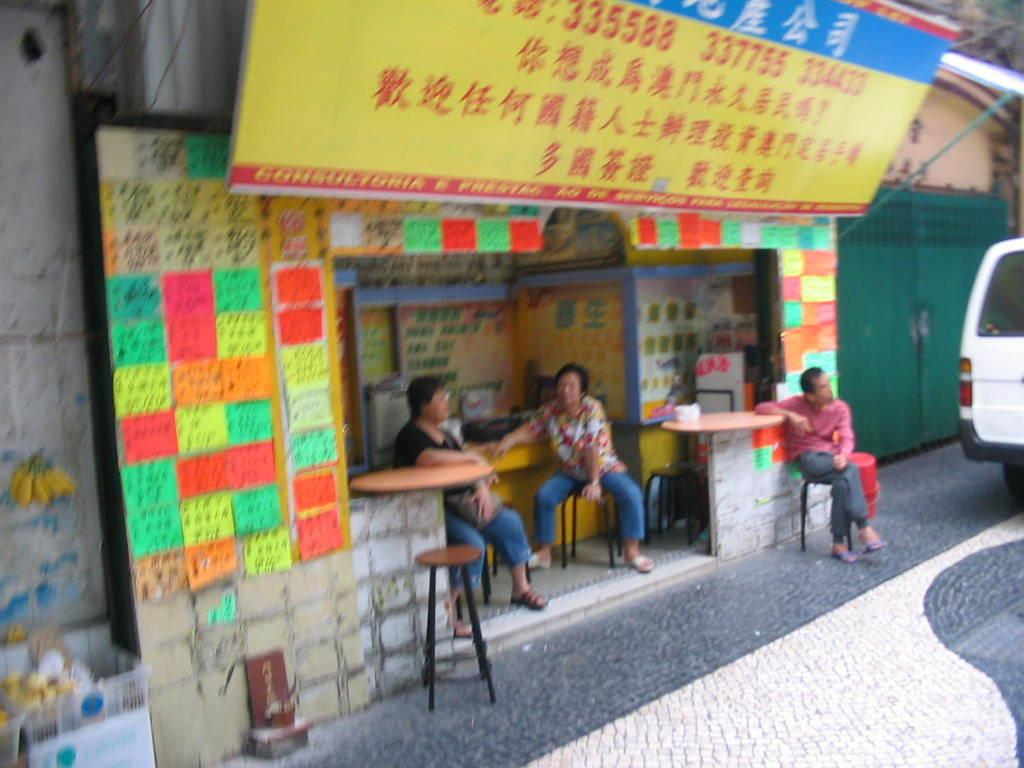How many people are in the image? There are three people in the image. What are the people doing in the image? The people are sitting on stools. What can be seen on the walls in the image? There are posters in the image. What is the location of the gates in the image? The gates are in the image. What is on the road in the image? There is a vehicle on the road in the image. What is used for carrying items in the image? There is a basket in the image for carrying items. Can you describe the unspecified objects in the image? Unfortunately, the facts provided do not specify the nature of the unspecified objects in the image. How many trees are growing in the image? There is no mention of trees in the image, so we cannot determine the number of trees present. What force is being applied to the people sitting on the stools? There is no indication of any force being applied to the people sitting on the stools in the image. 